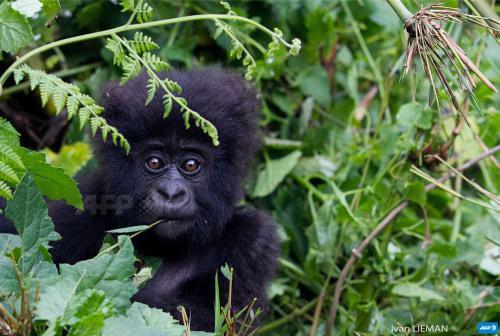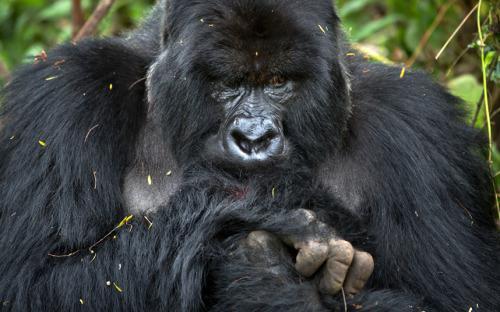The first image is the image on the left, the second image is the image on the right. For the images shown, is this caption "there is a long silverback gorilla on a hilltop overlooking a pool of water with fog" true? Answer yes or no. No. 